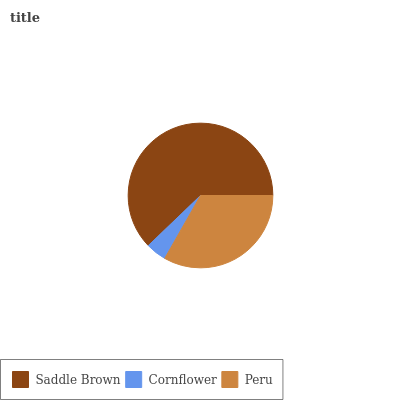Is Cornflower the minimum?
Answer yes or no. Yes. Is Saddle Brown the maximum?
Answer yes or no. Yes. Is Peru the minimum?
Answer yes or no. No. Is Peru the maximum?
Answer yes or no. No. Is Peru greater than Cornflower?
Answer yes or no. Yes. Is Cornflower less than Peru?
Answer yes or no. Yes. Is Cornflower greater than Peru?
Answer yes or no. No. Is Peru less than Cornflower?
Answer yes or no. No. Is Peru the high median?
Answer yes or no. Yes. Is Peru the low median?
Answer yes or no. Yes. Is Cornflower the high median?
Answer yes or no. No. Is Saddle Brown the low median?
Answer yes or no. No. 